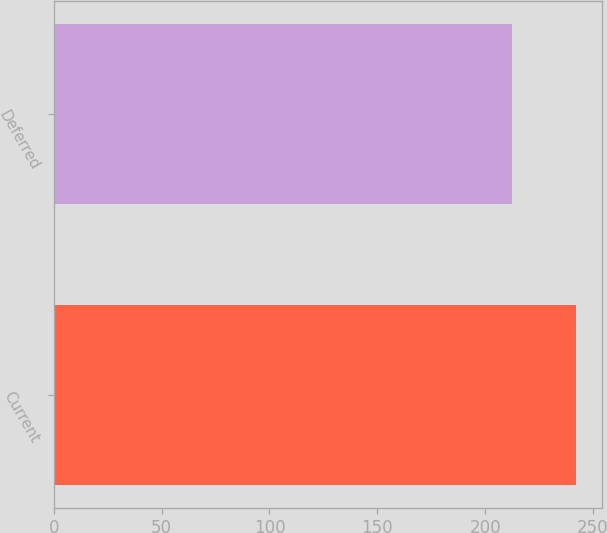Convert chart. <chart><loc_0><loc_0><loc_500><loc_500><bar_chart><fcel>Current<fcel>Deferred<nl><fcel>242.2<fcel>212.5<nl></chart> 